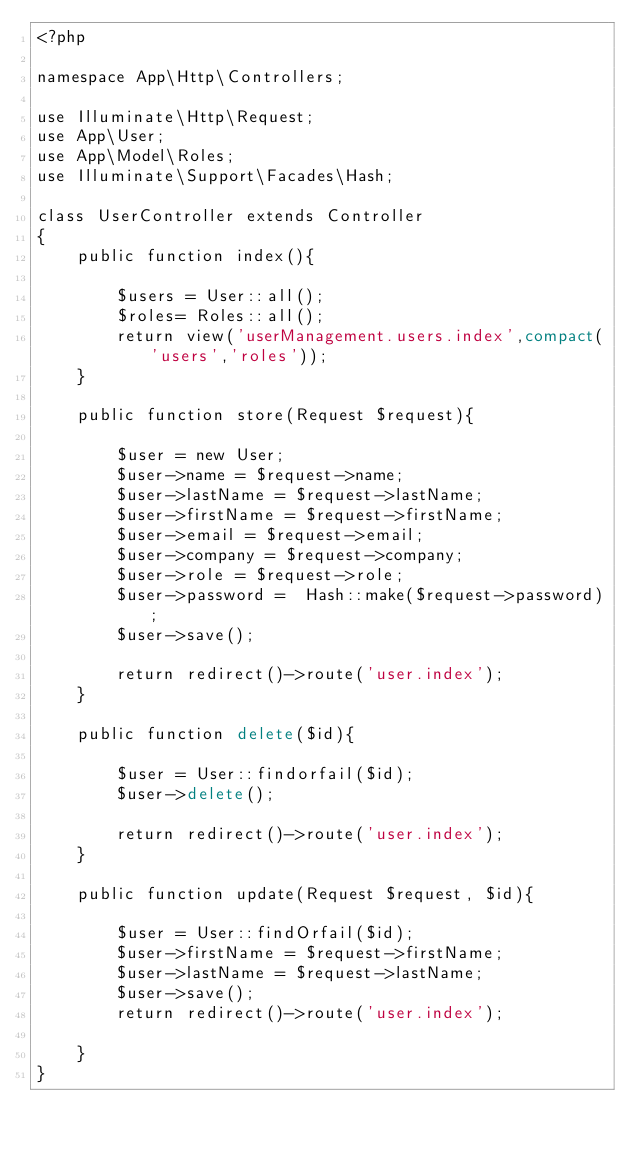<code> <loc_0><loc_0><loc_500><loc_500><_PHP_><?php

namespace App\Http\Controllers;

use Illuminate\Http\Request;
use App\User;
use App\Model\Roles;
use Illuminate\Support\Facades\Hash;

class UserController extends Controller
{
    public function index(){

        $users = User::all();
        $roles= Roles::all();
        return view('userManagement.users.index',compact('users','roles'));
    }

    public function store(Request $request){

        $user = new User;
        $user->name = $request->name;
        $user->lastName = $request->lastName;
        $user->firstName = $request->firstName;
        $user->email = $request->email;
        $user->company = $request->company;
        $user->role = $request->role;
        $user->password =  Hash::make($request->password);
        $user->save();

        return redirect()->route('user.index');
    }

    public function delete($id){
        
        $user = User::findorfail($id);
        $user->delete();

        return redirect()->route('user.index');
    }

    public function update(Request $request, $id){
        
        $user = User::findOrfail($id);
        $user->firstName = $request->firstName;
        $user->lastName = $request->lastName;
        $user->save();
        return redirect()->route('user.index');

    }
}
</code> 